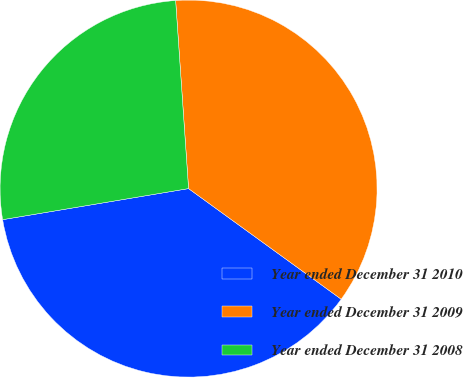Convert chart. <chart><loc_0><loc_0><loc_500><loc_500><pie_chart><fcel>Year ended December 31 2010<fcel>Year ended December 31 2009<fcel>Year ended December 31 2008<nl><fcel>37.38%<fcel>36.07%<fcel>26.54%<nl></chart> 